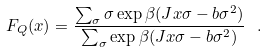Convert formula to latex. <formula><loc_0><loc_0><loc_500><loc_500>F _ { Q } ( x ) = \frac { \sum _ { \sigma } \sigma \exp { \beta ( J x \sigma - b \sigma ^ { 2 } ) } } { \sum _ { \sigma } \exp { \beta ( J x \sigma - b \sigma ^ { 2 } ) } } \ .</formula> 